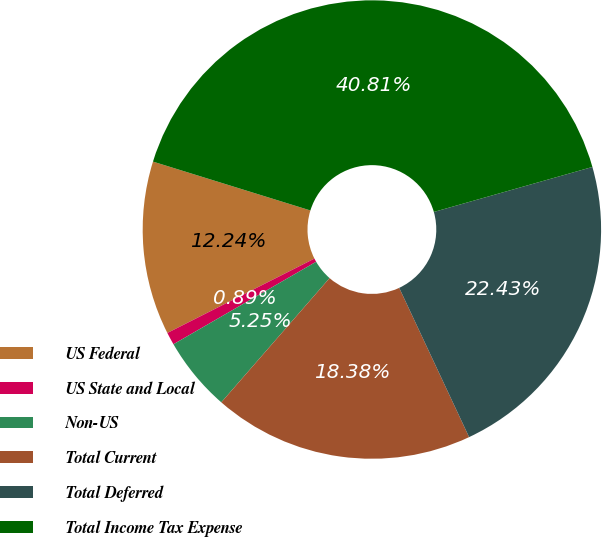Convert chart. <chart><loc_0><loc_0><loc_500><loc_500><pie_chart><fcel>US Federal<fcel>US State and Local<fcel>Non-US<fcel>Total Current<fcel>Total Deferred<fcel>Total Income Tax Expense<nl><fcel>12.24%<fcel>0.89%<fcel>5.25%<fcel>18.38%<fcel>22.43%<fcel>40.81%<nl></chart> 